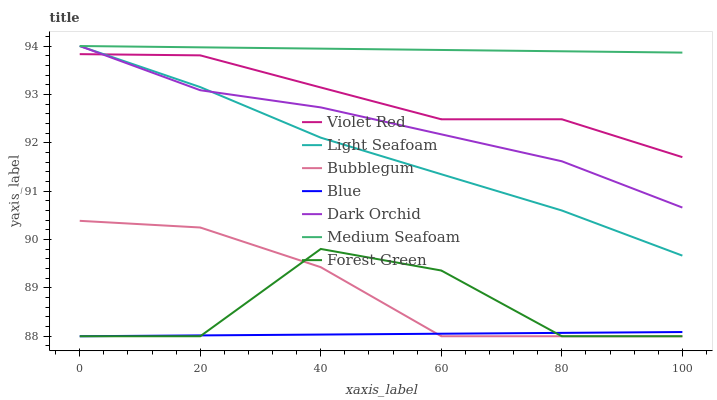Does Violet Red have the minimum area under the curve?
Answer yes or no. No. Does Violet Red have the maximum area under the curve?
Answer yes or no. No. Is Violet Red the smoothest?
Answer yes or no. No. Is Violet Red the roughest?
Answer yes or no. No. Does Violet Red have the lowest value?
Answer yes or no. No. Does Violet Red have the highest value?
Answer yes or no. No. Is Blue less than Medium Seafoam?
Answer yes or no. Yes. Is Dark Orchid greater than Blue?
Answer yes or no. Yes. Does Blue intersect Medium Seafoam?
Answer yes or no. No. 